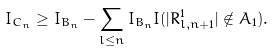Convert formula to latex. <formula><loc_0><loc_0><loc_500><loc_500>I _ { C _ { n } } & \geq I _ { B _ { n } } - \sum _ { l \leq n } I _ { B _ { n } } I ( | R _ { l , n + 1 } ^ { 1 } | \notin A _ { 1 } ) .</formula> 